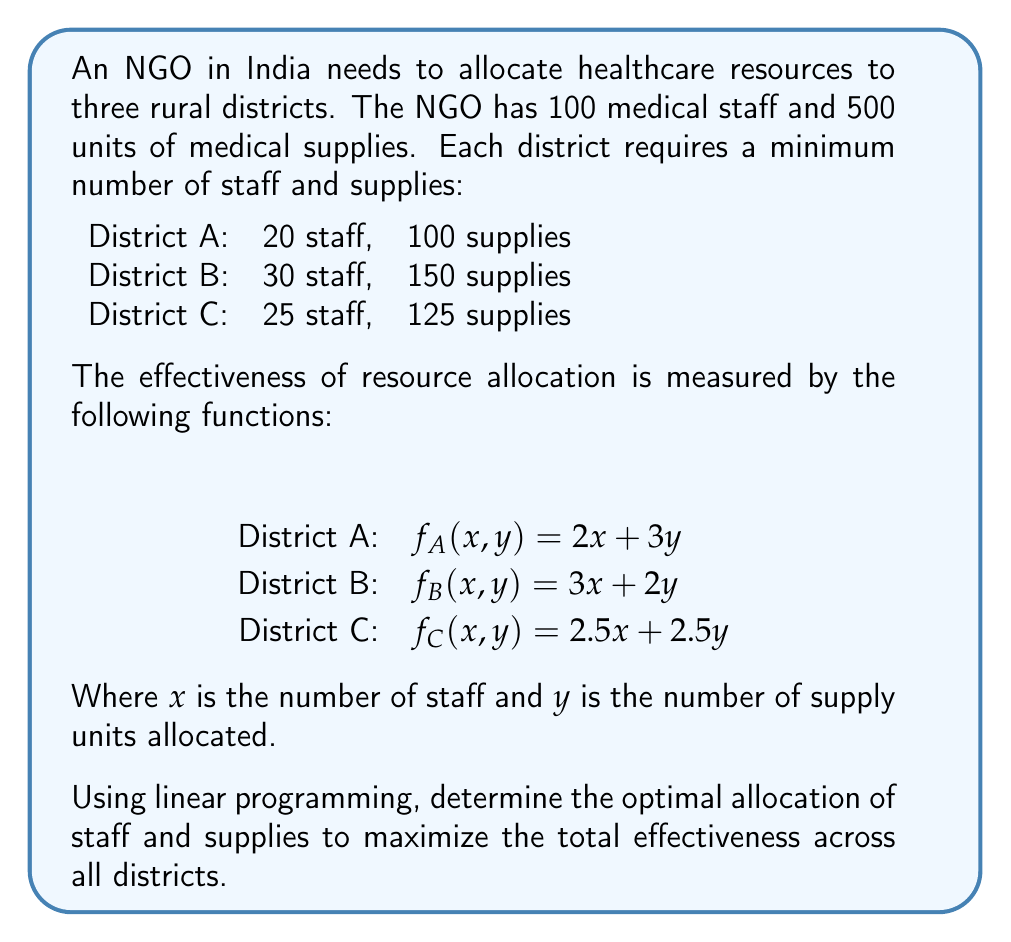Solve this math problem. To solve this linear programming problem, we'll follow these steps:

1) Define variables:
   Let $x_A, x_B, x_C$ be the number of staff allocated to districts A, B, and C respectively.
   Let $y_A, y_B, y_C$ be the number of supply units allocated to districts A, B, and C respectively.

2) Objective function:
   Maximize $Z = (2x_A + 3y_A) + (3x_B + 2y_B) + (2.5x_C + 2.5y_C)$

3) Constraints:
   Staff: $x_A + x_B + x_C \leq 100$
   Supplies: $y_A + y_B + y_C \leq 500$
   District A: $x_A \geq 20, y_A \geq 100$
   District B: $x_B \geq 30, y_B \geq 150$
   District C: $x_C \geq 25, y_C \geq 125$
   Non-negativity: $x_A, x_B, x_C, y_A, y_B, y_C \geq 0$

4) Solve using the simplex method or linear programming software.

5) The optimal solution:
   $x_A = 20, y_A = 100$
   $x_B = 55, y_B = 150$
   $x_C = 25, y_C = 250$

6) Verify constraints:
   Staff: $20 + 55 + 25 = 100$ (meets limit)
   Supplies: $100 + 150 + 250 = 500$ (meets limit)
   All district minimums are met.

7) Calculate maximum effectiveness:
   $Z = (2(20) + 3(100)) + (3(55) + 2(150)) + (2.5(25) + 2.5(250))$
   $Z = 340 + 465 + 687.5 = 1492.5$

Therefore, the optimal allocation to maximize effectiveness is:
District A: 20 staff, 100 supplies
District B: 55 staff, 150 supplies
District C: 25 staff, 250 supplies
Answer: A: 20 staff, 100 supplies; B: 55 staff, 150 supplies; C: 25 staff, 250 supplies; Max effectiveness: 1492.5 